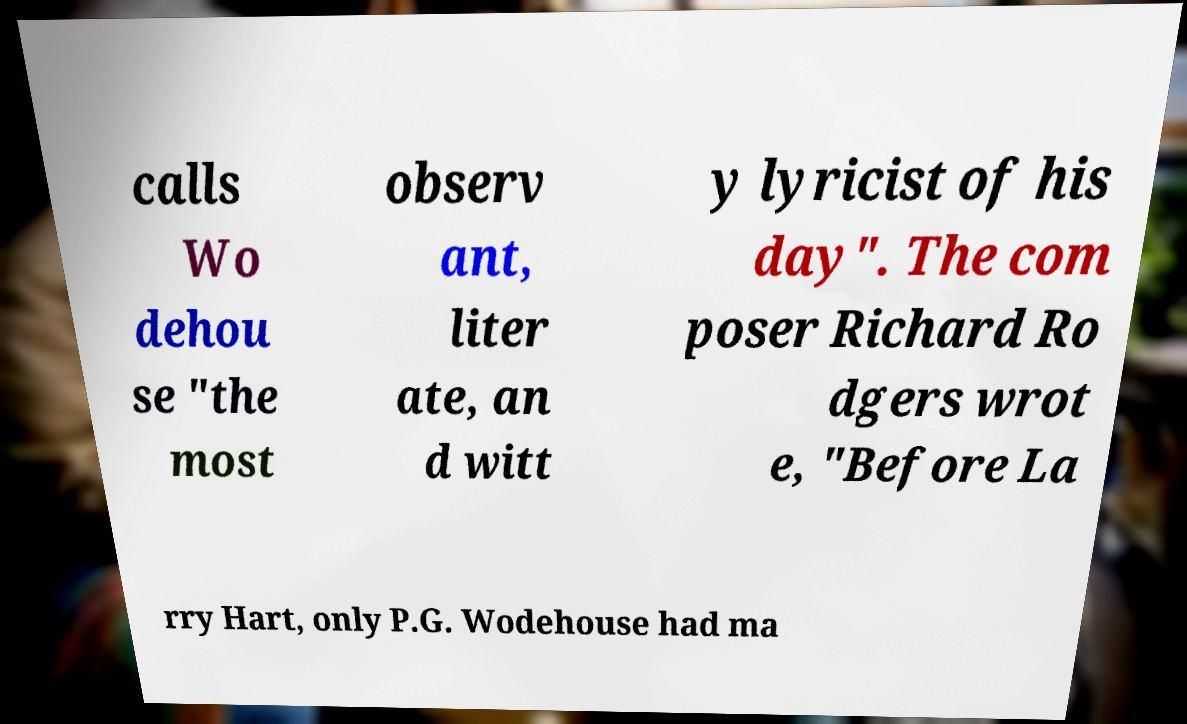There's text embedded in this image that I need extracted. Can you transcribe it verbatim? calls Wo dehou se "the most observ ant, liter ate, an d witt y lyricist of his day". The com poser Richard Ro dgers wrot e, "Before La rry Hart, only P.G. Wodehouse had ma 